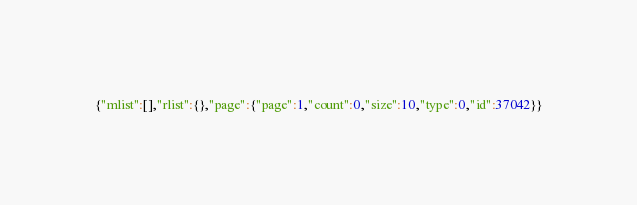<code> <loc_0><loc_0><loc_500><loc_500><_JavaScript_>{"mlist":[],"rlist":{},"page":{"page":1,"count":0,"size":10,"type":0,"id":37042}}</code> 